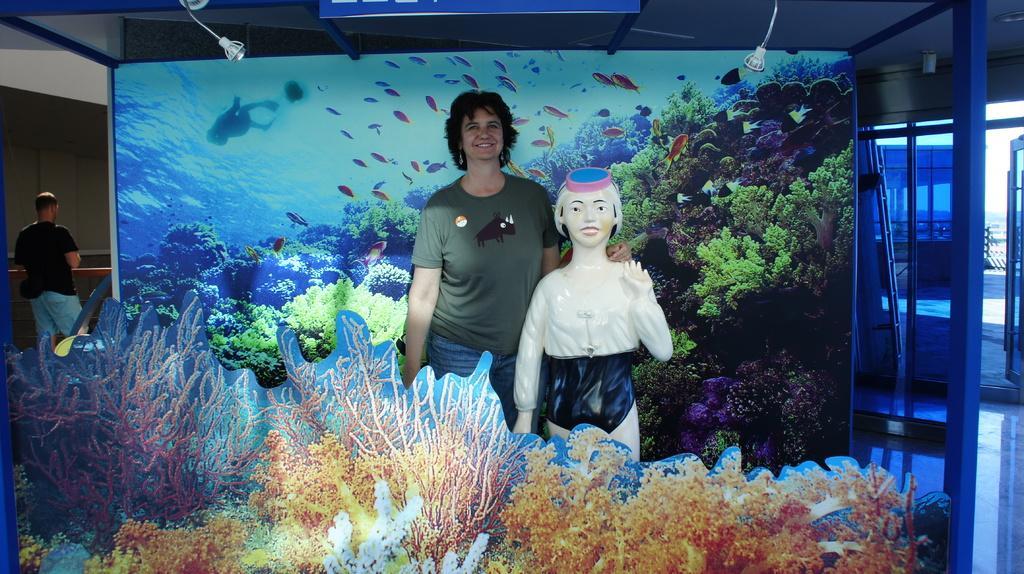Describe this image in one or two sentences. In this image in the center there is one woman who is standing and smiling, and beside her there is one toy. At the bottom there are some pictures of plant, and in the background there is a board. On the board there are some water plants, river and some fishes. And on the left side there is one person, on the right side there are glass doors and some objects. At the bottom there is floor, and at the top there is ceiling and light. 